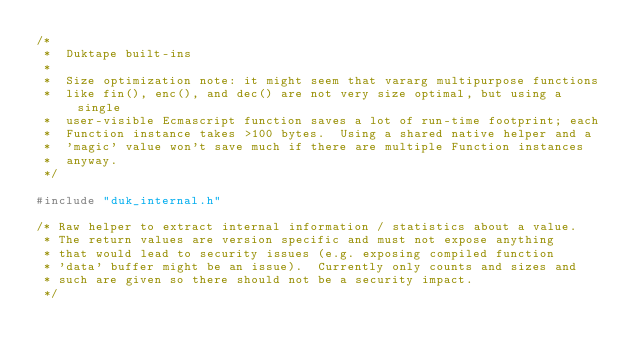Convert code to text. <code><loc_0><loc_0><loc_500><loc_500><_C_>/*
 *  Duktape built-ins
 *
 *  Size optimization note: it might seem that vararg multipurpose functions
 *  like fin(), enc(), and dec() are not very size optimal, but using a single
 *  user-visible Ecmascript function saves a lot of run-time footprint; each
 *  Function instance takes >100 bytes.  Using a shared native helper and a
 *  'magic' value won't save much if there are multiple Function instances
 *  anyway.
 */

#include "duk_internal.h"

/* Raw helper to extract internal information / statistics about a value.
 * The return values are version specific and must not expose anything
 * that would lead to security issues (e.g. exposing compiled function
 * 'data' buffer might be an issue).  Currently only counts and sizes and
 * such are given so there should not be a security impact.
 */</code> 